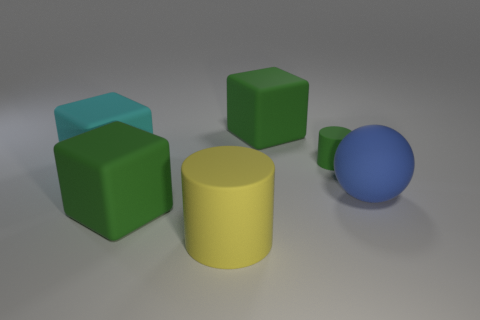Do the small cylinder and the cyan thing have the same material?
Give a very brief answer. Yes. What material is the yellow thing that is the same shape as the small green thing?
Give a very brief answer. Rubber. Are there fewer cyan matte things right of the big sphere than green matte cylinders?
Ensure brevity in your answer.  Yes. How many tiny objects are behind the blue matte thing?
Your response must be concise. 1. Do the green matte object that is left of the large yellow cylinder and the green matte thing behind the green cylinder have the same shape?
Provide a short and direct response. Yes. There is a thing that is in front of the big cyan block and on the right side of the large yellow thing; what is its shape?
Offer a very short reply. Sphere. What is the size of the cyan block that is made of the same material as the blue thing?
Offer a very short reply. Large. Are there fewer big purple matte cubes than blue balls?
Provide a succinct answer. Yes. What material is the cube that is on the right side of the large green block that is left of the large green rubber thing that is on the right side of the large yellow object?
Give a very brief answer. Rubber. Does the green object in front of the cyan matte block have the same material as the cube that is behind the green cylinder?
Provide a short and direct response. Yes. 